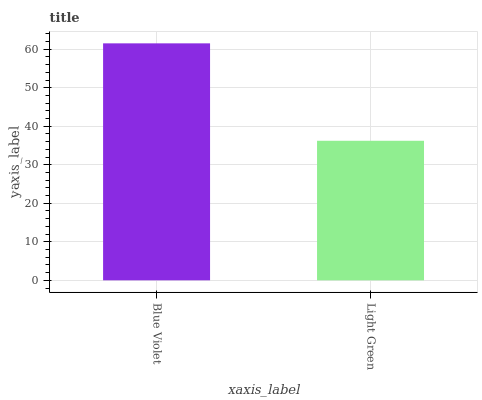Is Light Green the minimum?
Answer yes or no. Yes. Is Blue Violet the maximum?
Answer yes or no. Yes. Is Light Green the maximum?
Answer yes or no. No. Is Blue Violet greater than Light Green?
Answer yes or no. Yes. Is Light Green less than Blue Violet?
Answer yes or no. Yes. Is Light Green greater than Blue Violet?
Answer yes or no. No. Is Blue Violet less than Light Green?
Answer yes or no. No. Is Blue Violet the high median?
Answer yes or no. Yes. Is Light Green the low median?
Answer yes or no. Yes. Is Light Green the high median?
Answer yes or no. No. Is Blue Violet the low median?
Answer yes or no. No. 